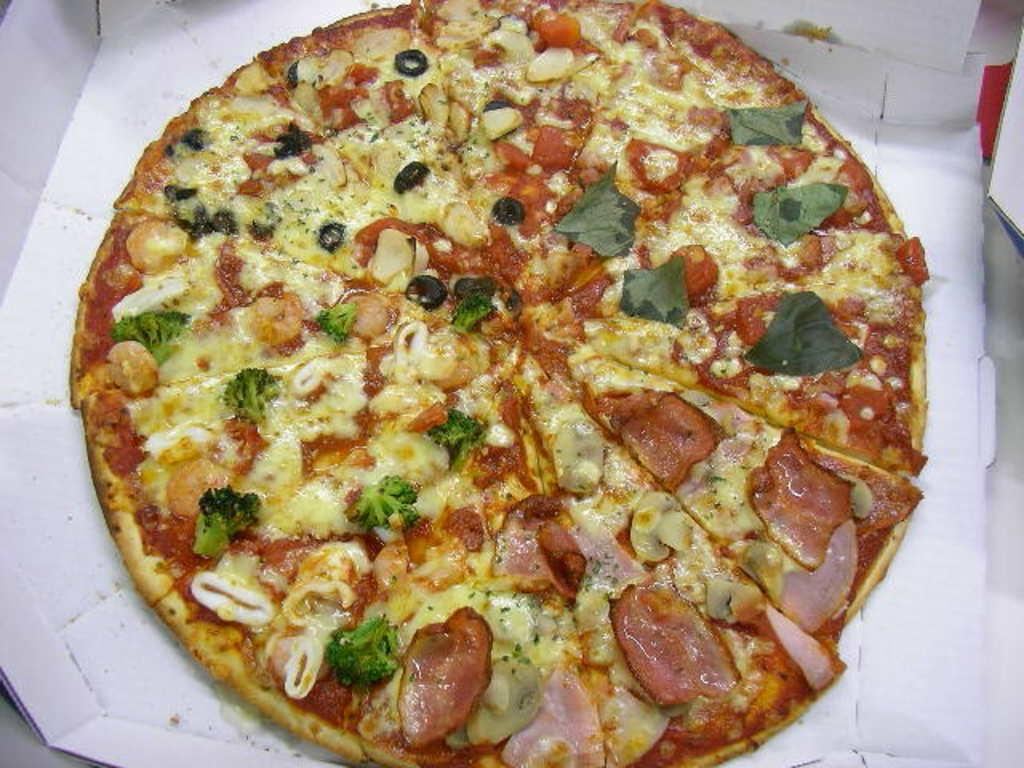What type of food is the main subject of the image? There is a large pizza in the image. What ingredients are visible on the pizza? The pizza has veggies, meat, and cheese on it. What container is present in the image? There is a box in the image. How many jellyfish can be seen swimming in the ocean in the image? There are no jellyfish or ocean present in the image; it features a large pizza with various toppings and a box. 